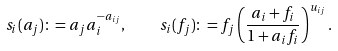<formula> <loc_0><loc_0><loc_500><loc_500>s _ { i } ( a _ { j } ) \colon = a _ { j } a _ { i } ^ { - a _ { i j } } , \quad s _ { i } ( f _ { j } ) \colon = f _ { j } \left ( \frac { a _ { i } + f _ { i } } { 1 + a _ { i } f _ { i } } \right ) ^ { u _ { i j } } .</formula> 